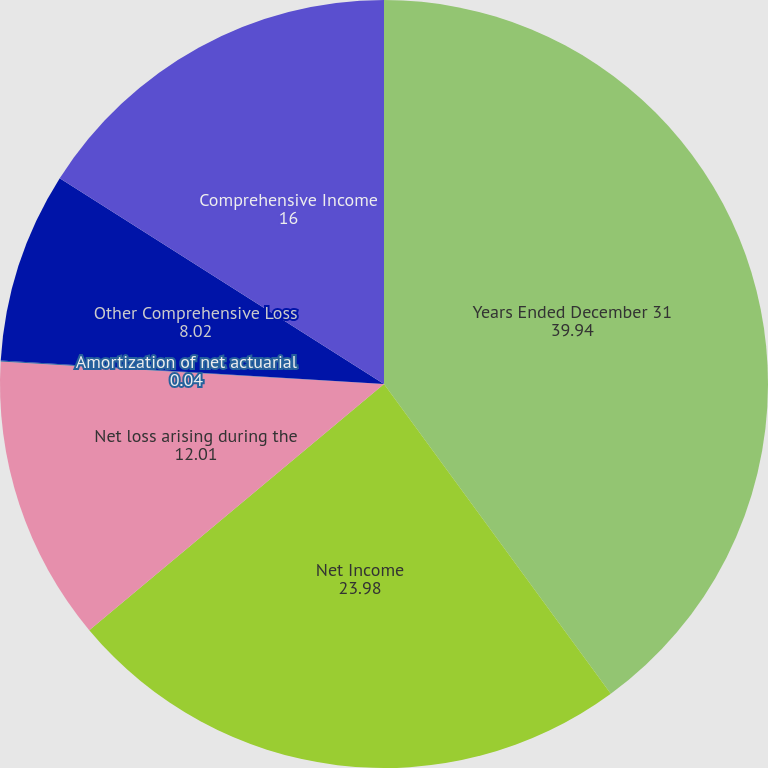<chart> <loc_0><loc_0><loc_500><loc_500><pie_chart><fcel>Years Ended December 31<fcel>Net Income<fcel>Net loss arising during the<fcel>Amortization of net actuarial<fcel>Other Comprehensive Loss<fcel>Comprehensive Income<nl><fcel>39.94%<fcel>23.98%<fcel>12.01%<fcel>0.04%<fcel>8.02%<fcel>16.0%<nl></chart> 